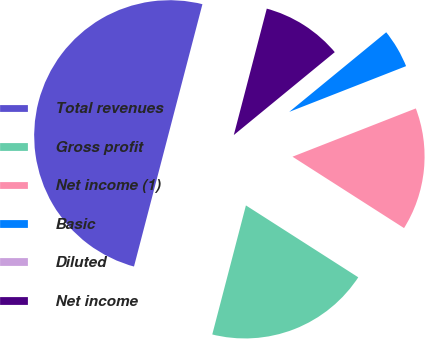Convert chart. <chart><loc_0><loc_0><loc_500><loc_500><pie_chart><fcel>Total revenues<fcel>Gross profit<fcel>Net income (1)<fcel>Basic<fcel>Diluted<fcel>Net income<nl><fcel>50.0%<fcel>20.0%<fcel>15.0%<fcel>5.0%<fcel>0.0%<fcel>10.0%<nl></chart> 